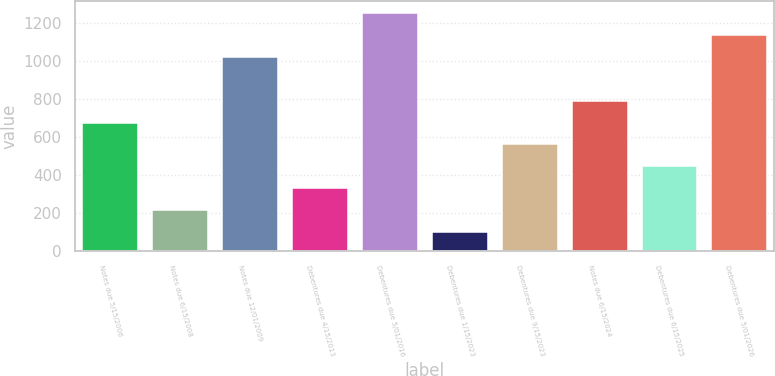Convert chart. <chart><loc_0><loc_0><loc_500><loc_500><bar_chart><fcel>Notes due 5/15/2006<fcel>Notes due 6/15/2008<fcel>Notes due 12/01/2009<fcel>Debentures due 4/15/2013<fcel>Debentures due 5/01/2016<fcel>Debentures due 1/15/2023<fcel>Debentures due 9/15/2023<fcel>Notes due 6/15/2024<fcel>Debentures due 6/15/2025<fcel>Debentures due 5/01/2026<nl><fcel>675<fcel>215<fcel>1020<fcel>330<fcel>1250<fcel>100<fcel>560<fcel>790<fcel>445<fcel>1135<nl></chart> 